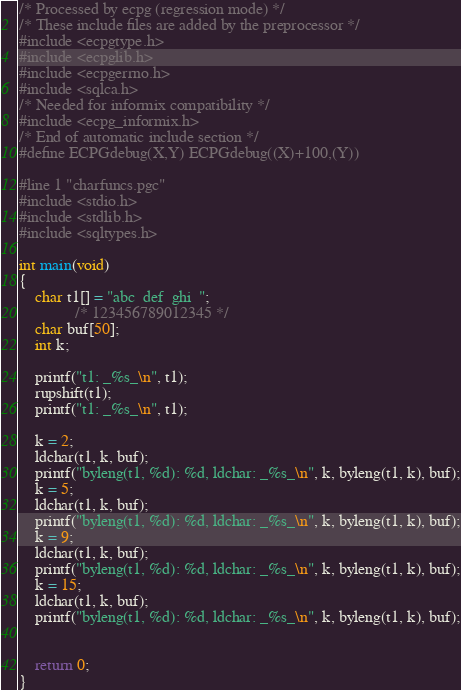Convert code to text. <code><loc_0><loc_0><loc_500><loc_500><_C_>/* Processed by ecpg (regression mode) */
/* These include files are added by the preprocessor */
#include <ecpgtype.h>
#include <ecpglib.h>
#include <ecpgerrno.h>
#include <sqlca.h>
/* Needed for informix compatibility */
#include <ecpg_informix.h>
/* End of automatic include section */
#define ECPGdebug(X,Y) ECPGdebug((X)+100,(Y))

#line 1 "charfuncs.pgc"
#include <stdio.h>
#include <stdlib.h>
#include <sqltypes.h>

int main(void)
{
	char t1[] = "abc  def  ghi  ";
	          /* 123456789012345 */
	char buf[50];
	int k;

	printf("t1: _%s_\n", t1);
	rupshift(t1);
	printf("t1: _%s_\n", t1);

	k = 2;
	ldchar(t1, k, buf);
	printf("byleng(t1, %d): %d, ldchar: _%s_\n", k, byleng(t1, k), buf);
	k = 5;
	ldchar(t1, k, buf);
	printf("byleng(t1, %d): %d, ldchar: _%s_\n", k, byleng(t1, k), buf);
	k = 9;
	ldchar(t1, k, buf);
	printf("byleng(t1, %d): %d, ldchar: _%s_\n", k, byleng(t1, k), buf);
	k = 15;
	ldchar(t1, k, buf);
	printf("byleng(t1, %d): %d, ldchar: _%s_\n", k, byleng(t1, k), buf);


	return 0;
}
</code> 